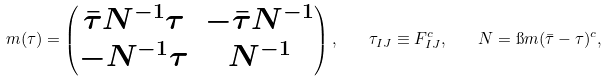Convert formula to latex. <formula><loc_0><loc_0><loc_500><loc_500>m ( \tau ) = \begin{pmatrix} \bar { \tau } N ^ { - 1 } \tau & - \bar { \tau } N ^ { - 1 } \\ - N ^ { - 1 } \tau & N ^ { - 1 } \end{pmatrix} , \quad \tau _ { I J } \equiv F _ { I J } ^ { c } , \quad N = \i m ( \bar { \tau } - \tau ) ^ { c } ,</formula> 